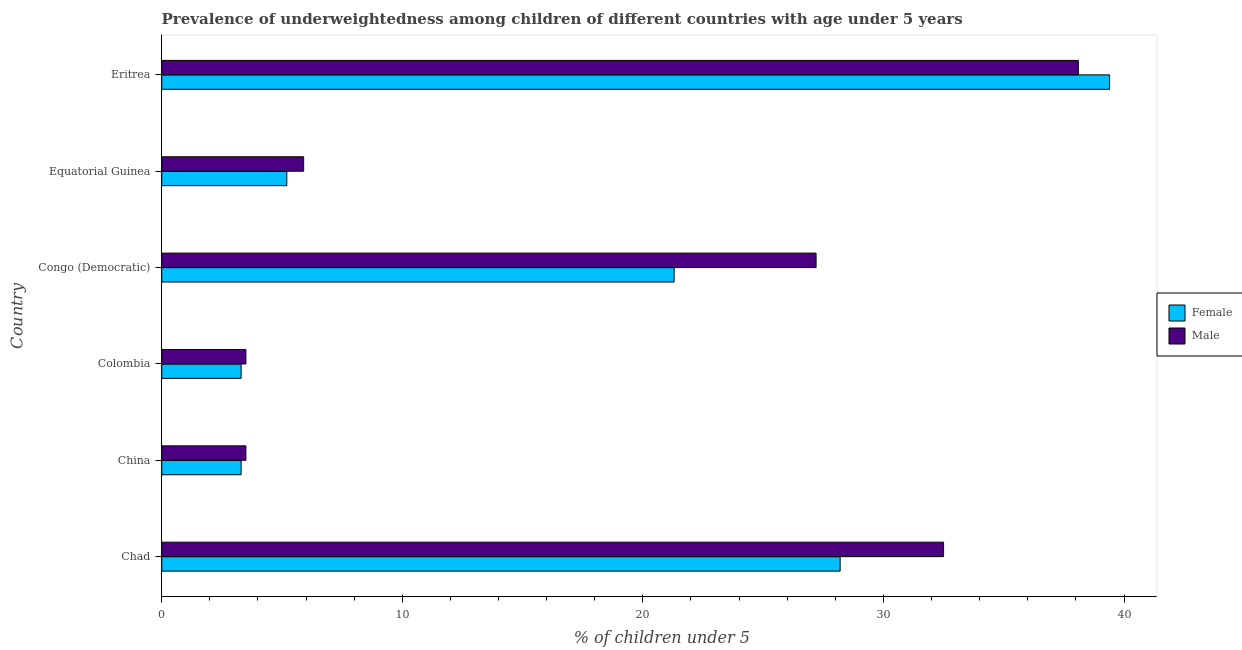How many different coloured bars are there?
Offer a very short reply. 2. How many groups of bars are there?
Provide a succinct answer. 6. How many bars are there on the 3rd tick from the bottom?
Provide a succinct answer. 2. What is the label of the 5th group of bars from the top?
Provide a succinct answer. China. In how many cases, is the number of bars for a given country not equal to the number of legend labels?
Offer a very short reply. 0. What is the percentage of underweighted male children in Eritrea?
Make the answer very short. 38.1. Across all countries, what is the maximum percentage of underweighted female children?
Offer a very short reply. 39.4. In which country was the percentage of underweighted female children maximum?
Keep it short and to the point. Eritrea. What is the total percentage of underweighted female children in the graph?
Give a very brief answer. 100.7. What is the difference between the percentage of underweighted male children in Chad and that in Equatorial Guinea?
Provide a succinct answer. 26.6. What is the difference between the percentage of underweighted female children in Eritrea and the percentage of underweighted male children in Chad?
Your answer should be very brief. 6.9. What is the average percentage of underweighted female children per country?
Your response must be concise. 16.78. In how many countries, is the percentage of underweighted female children greater than 38 %?
Offer a terse response. 1. What is the ratio of the percentage of underweighted male children in Chad to that in Congo (Democratic)?
Provide a succinct answer. 1.2. Is the percentage of underweighted male children in Equatorial Guinea less than that in Eritrea?
Your response must be concise. Yes. Is the difference between the percentage of underweighted female children in Chad and Colombia greater than the difference between the percentage of underweighted male children in Chad and Colombia?
Keep it short and to the point. No. What is the difference between the highest and the lowest percentage of underweighted male children?
Offer a terse response. 34.6. In how many countries, is the percentage of underweighted male children greater than the average percentage of underweighted male children taken over all countries?
Offer a terse response. 3. What does the 1st bar from the top in Equatorial Guinea represents?
Provide a short and direct response. Male. How many bars are there?
Make the answer very short. 12. What is the difference between two consecutive major ticks on the X-axis?
Ensure brevity in your answer.  10. Are the values on the major ticks of X-axis written in scientific E-notation?
Ensure brevity in your answer.  No. Does the graph contain any zero values?
Make the answer very short. No. Does the graph contain grids?
Your answer should be compact. No. Where does the legend appear in the graph?
Your response must be concise. Center right. How many legend labels are there?
Your answer should be compact. 2. How are the legend labels stacked?
Keep it short and to the point. Vertical. What is the title of the graph?
Offer a very short reply. Prevalence of underweightedness among children of different countries with age under 5 years. What is the label or title of the X-axis?
Provide a succinct answer.  % of children under 5. What is the label or title of the Y-axis?
Ensure brevity in your answer.  Country. What is the  % of children under 5 of Female in Chad?
Your answer should be very brief. 28.2. What is the  % of children under 5 in Male in Chad?
Your answer should be compact. 32.5. What is the  % of children under 5 of Female in China?
Provide a short and direct response. 3.3. What is the  % of children under 5 in Female in Colombia?
Your answer should be very brief. 3.3. What is the  % of children under 5 in Male in Colombia?
Keep it short and to the point. 3.5. What is the  % of children under 5 in Female in Congo (Democratic)?
Ensure brevity in your answer.  21.3. What is the  % of children under 5 of Male in Congo (Democratic)?
Ensure brevity in your answer.  27.2. What is the  % of children under 5 of Female in Equatorial Guinea?
Make the answer very short. 5.2. What is the  % of children under 5 of Male in Equatorial Guinea?
Provide a succinct answer. 5.9. What is the  % of children under 5 in Female in Eritrea?
Provide a succinct answer. 39.4. What is the  % of children under 5 of Male in Eritrea?
Offer a very short reply. 38.1. Across all countries, what is the maximum  % of children under 5 of Female?
Your answer should be very brief. 39.4. Across all countries, what is the maximum  % of children under 5 of Male?
Keep it short and to the point. 38.1. Across all countries, what is the minimum  % of children under 5 of Female?
Offer a very short reply. 3.3. Across all countries, what is the minimum  % of children under 5 of Male?
Your answer should be compact. 3.5. What is the total  % of children under 5 in Female in the graph?
Your response must be concise. 100.7. What is the total  % of children under 5 of Male in the graph?
Offer a terse response. 110.7. What is the difference between the  % of children under 5 of Female in Chad and that in China?
Keep it short and to the point. 24.9. What is the difference between the  % of children under 5 of Male in Chad and that in China?
Your answer should be compact. 29. What is the difference between the  % of children under 5 of Female in Chad and that in Colombia?
Make the answer very short. 24.9. What is the difference between the  % of children under 5 in Female in Chad and that in Congo (Democratic)?
Your answer should be very brief. 6.9. What is the difference between the  % of children under 5 in Male in Chad and that in Congo (Democratic)?
Your answer should be compact. 5.3. What is the difference between the  % of children under 5 in Female in Chad and that in Equatorial Guinea?
Your answer should be very brief. 23. What is the difference between the  % of children under 5 of Male in Chad and that in Equatorial Guinea?
Make the answer very short. 26.6. What is the difference between the  % of children under 5 in Male in Chad and that in Eritrea?
Keep it short and to the point. -5.6. What is the difference between the  % of children under 5 of Female in China and that in Colombia?
Make the answer very short. 0. What is the difference between the  % of children under 5 of Male in China and that in Congo (Democratic)?
Ensure brevity in your answer.  -23.7. What is the difference between the  % of children under 5 in Male in China and that in Equatorial Guinea?
Your answer should be compact. -2.4. What is the difference between the  % of children under 5 of Female in China and that in Eritrea?
Provide a succinct answer. -36.1. What is the difference between the  % of children under 5 in Male in China and that in Eritrea?
Give a very brief answer. -34.6. What is the difference between the  % of children under 5 of Female in Colombia and that in Congo (Democratic)?
Keep it short and to the point. -18. What is the difference between the  % of children under 5 in Male in Colombia and that in Congo (Democratic)?
Make the answer very short. -23.7. What is the difference between the  % of children under 5 in Female in Colombia and that in Eritrea?
Offer a very short reply. -36.1. What is the difference between the  % of children under 5 of Male in Colombia and that in Eritrea?
Keep it short and to the point. -34.6. What is the difference between the  % of children under 5 in Female in Congo (Democratic) and that in Equatorial Guinea?
Your answer should be very brief. 16.1. What is the difference between the  % of children under 5 in Male in Congo (Democratic) and that in Equatorial Guinea?
Your answer should be very brief. 21.3. What is the difference between the  % of children under 5 in Female in Congo (Democratic) and that in Eritrea?
Give a very brief answer. -18.1. What is the difference between the  % of children under 5 in Male in Congo (Democratic) and that in Eritrea?
Your response must be concise. -10.9. What is the difference between the  % of children under 5 in Female in Equatorial Guinea and that in Eritrea?
Give a very brief answer. -34.2. What is the difference between the  % of children under 5 in Male in Equatorial Guinea and that in Eritrea?
Give a very brief answer. -32.2. What is the difference between the  % of children under 5 in Female in Chad and the  % of children under 5 in Male in China?
Ensure brevity in your answer.  24.7. What is the difference between the  % of children under 5 in Female in Chad and the  % of children under 5 in Male in Colombia?
Offer a terse response. 24.7. What is the difference between the  % of children under 5 of Female in Chad and the  % of children under 5 of Male in Congo (Democratic)?
Your answer should be very brief. 1. What is the difference between the  % of children under 5 in Female in Chad and the  % of children under 5 in Male in Equatorial Guinea?
Make the answer very short. 22.3. What is the difference between the  % of children under 5 of Female in Chad and the  % of children under 5 of Male in Eritrea?
Your response must be concise. -9.9. What is the difference between the  % of children under 5 of Female in China and the  % of children under 5 of Male in Congo (Democratic)?
Offer a terse response. -23.9. What is the difference between the  % of children under 5 in Female in China and the  % of children under 5 in Male in Eritrea?
Keep it short and to the point. -34.8. What is the difference between the  % of children under 5 of Female in Colombia and the  % of children under 5 of Male in Congo (Democratic)?
Offer a terse response. -23.9. What is the difference between the  % of children under 5 of Female in Colombia and the  % of children under 5 of Male in Eritrea?
Your answer should be very brief. -34.8. What is the difference between the  % of children under 5 of Female in Congo (Democratic) and the  % of children under 5 of Male in Eritrea?
Provide a succinct answer. -16.8. What is the difference between the  % of children under 5 in Female in Equatorial Guinea and the  % of children under 5 in Male in Eritrea?
Make the answer very short. -32.9. What is the average  % of children under 5 in Female per country?
Your response must be concise. 16.78. What is the average  % of children under 5 of Male per country?
Your answer should be very brief. 18.45. What is the difference between the  % of children under 5 of Female and  % of children under 5 of Male in Chad?
Keep it short and to the point. -4.3. What is the difference between the  % of children under 5 in Female and  % of children under 5 in Male in Colombia?
Your answer should be compact. -0.2. What is the difference between the  % of children under 5 in Female and  % of children under 5 in Male in Congo (Democratic)?
Ensure brevity in your answer.  -5.9. What is the difference between the  % of children under 5 of Female and  % of children under 5 of Male in Equatorial Guinea?
Your answer should be compact. -0.7. What is the ratio of the  % of children under 5 of Female in Chad to that in China?
Provide a short and direct response. 8.55. What is the ratio of the  % of children under 5 in Male in Chad to that in China?
Provide a short and direct response. 9.29. What is the ratio of the  % of children under 5 of Female in Chad to that in Colombia?
Your answer should be very brief. 8.55. What is the ratio of the  % of children under 5 of Male in Chad to that in Colombia?
Your answer should be compact. 9.29. What is the ratio of the  % of children under 5 in Female in Chad to that in Congo (Democratic)?
Provide a short and direct response. 1.32. What is the ratio of the  % of children under 5 in Male in Chad to that in Congo (Democratic)?
Ensure brevity in your answer.  1.19. What is the ratio of the  % of children under 5 in Female in Chad to that in Equatorial Guinea?
Your answer should be compact. 5.42. What is the ratio of the  % of children under 5 of Male in Chad to that in Equatorial Guinea?
Ensure brevity in your answer.  5.51. What is the ratio of the  % of children under 5 in Female in Chad to that in Eritrea?
Offer a terse response. 0.72. What is the ratio of the  % of children under 5 of Male in Chad to that in Eritrea?
Give a very brief answer. 0.85. What is the ratio of the  % of children under 5 in Female in China to that in Colombia?
Make the answer very short. 1. What is the ratio of the  % of children under 5 in Female in China to that in Congo (Democratic)?
Keep it short and to the point. 0.15. What is the ratio of the  % of children under 5 of Male in China to that in Congo (Democratic)?
Provide a short and direct response. 0.13. What is the ratio of the  % of children under 5 of Female in China to that in Equatorial Guinea?
Give a very brief answer. 0.63. What is the ratio of the  % of children under 5 of Male in China to that in Equatorial Guinea?
Ensure brevity in your answer.  0.59. What is the ratio of the  % of children under 5 in Female in China to that in Eritrea?
Give a very brief answer. 0.08. What is the ratio of the  % of children under 5 in Male in China to that in Eritrea?
Give a very brief answer. 0.09. What is the ratio of the  % of children under 5 of Female in Colombia to that in Congo (Democratic)?
Make the answer very short. 0.15. What is the ratio of the  % of children under 5 of Male in Colombia to that in Congo (Democratic)?
Ensure brevity in your answer.  0.13. What is the ratio of the  % of children under 5 of Female in Colombia to that in Equatorial Guinea?
Give a very brief answer. 0.63. What is the ratio of the  % of children under 5 of Male in Colombia to that in Equatorial Guinea?
Ensure brevity in your answer.  0.59. What is the ratio of the  % of children under 5 in Female in Colombia to that in Eritrea?
Offer a very short reply. 0.08. What is the ratio of the  % of children under 5 of Male in Colombia to that in Eritrea?
Ensure brevity in your answer.  0.09. What is the ratio of the  % of children under 5 of Female in Congo (Democratic) to that in Equatorial Guinea?
Provide a short and direct response. 4.1. What is the ratio of the  % of children under 5 of Male in Congo (Democratic) to that in Equatorial Guinea?
Your answer should be very brief. 4.61. What is the ratio of the  % of children under 5 in Female in Congo (Democratic) to that in Eritrea?
Make the answer very short. 0.54. What is the ratio of the  % of children under 5 in Male in Congo (Democratic) to that in Eritrea?
Offer a very short reply. 0.71. What is the ratio of the  % of children under 5 of Female in Equatorial Guinea to that in Eritrea?
Keep it short and to the point. 0.13. What is the ratio of the  % of children under 5 in Male in Equatorial Guinea to that in Eritrea?
Ensure brevity in your answer.  0.15. What is the difference between the highest and the second highest  % of children under 5 of Female?
Your answer should be very brief. 11.2. What is the difference between the highest and the second highest  % of children under 5 of Male?
Ensure brevity in your answer.  5.6. What is the difference between the highest and the lowest  % of children under 5 in Female?
Your answer should be very brief. 36.1. What is the difference between the highest and the lowest  % of children under 5 of Male?
Your response must be concise. 34.6. 